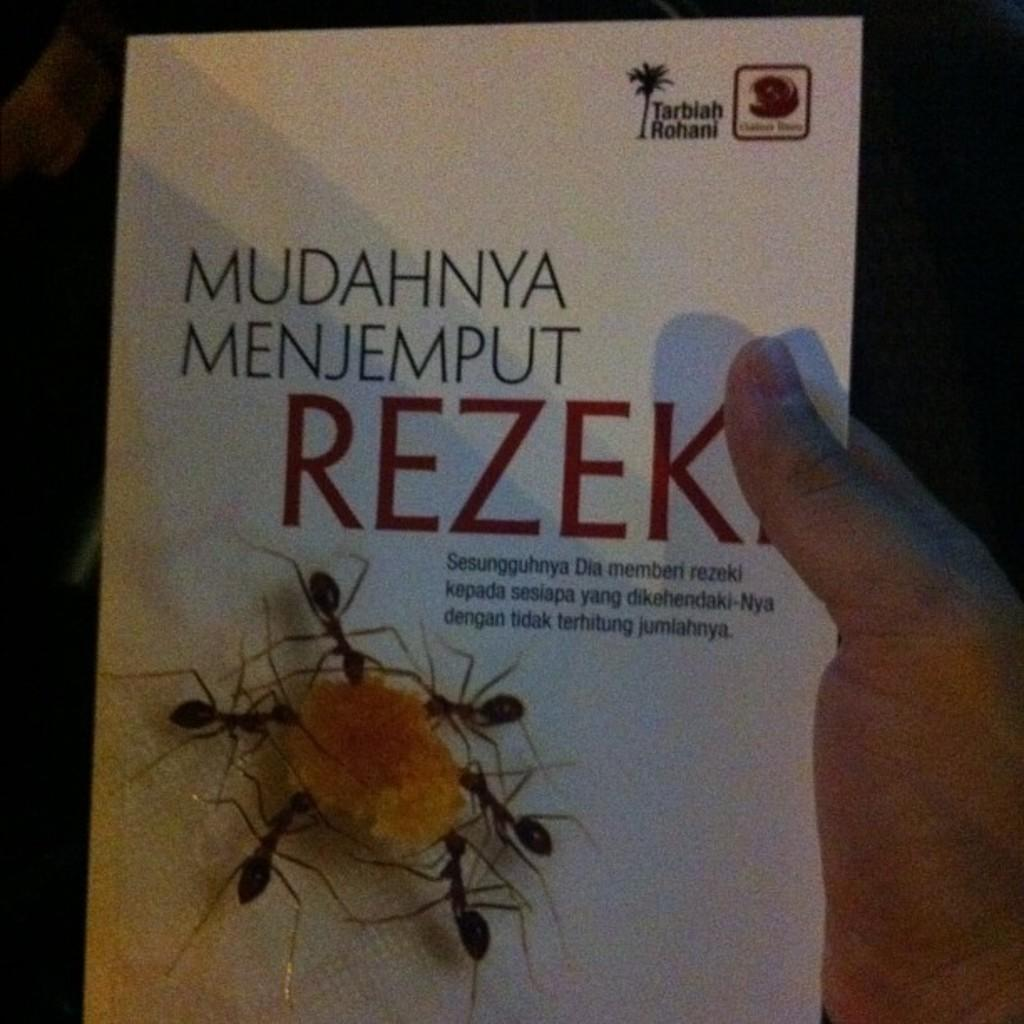What is being held by the person's hand in the image? There is a person's hand holding a poster in the image. What can be found on the poster? The poster contains text and images. What type of locket is the person wearing in the image? There is no information about a locket or any type of jewelry in the image. 